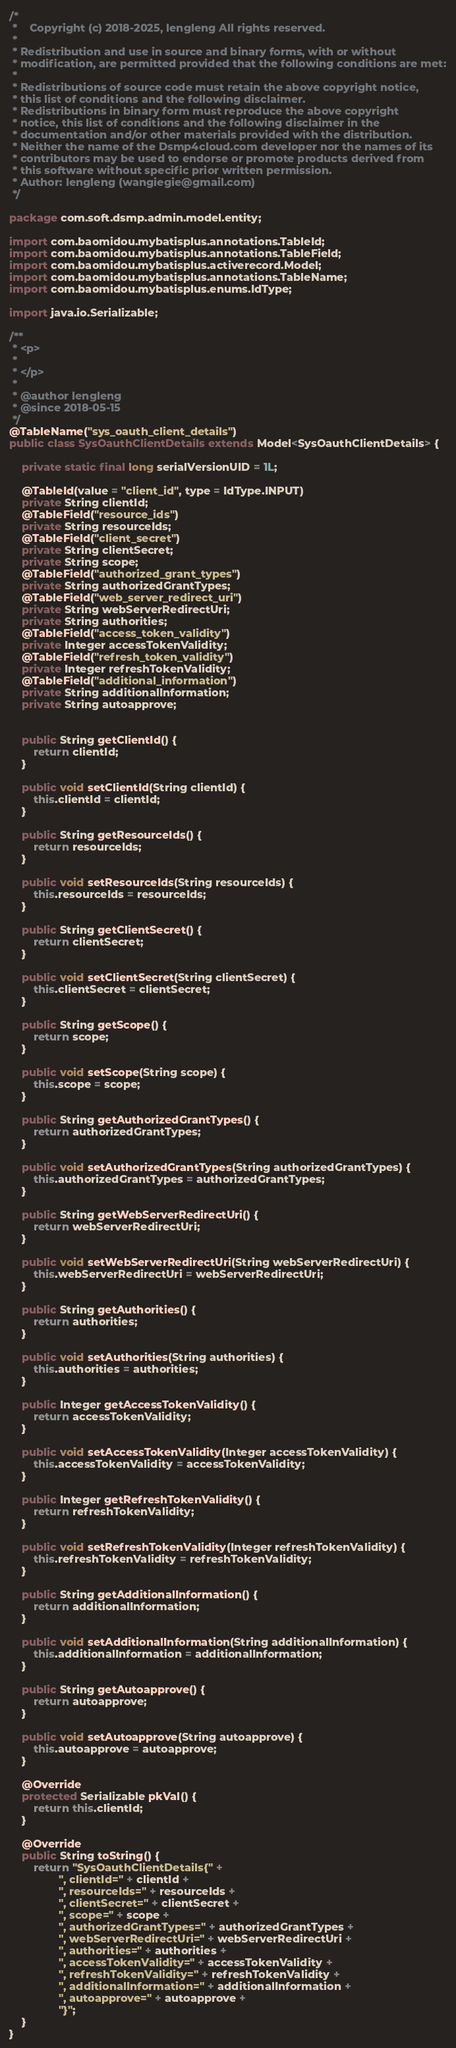<code> <loc_0><loc_0><loc_500><loc_500><_Java_>/*
 *    Copyright (c) 2018-2025, lengleng All rights reserved.
 *
 * Redistribution and use in source and binary forms, with or without
 * modification, are permitted provided that the following conditions are met:
 *
 * Redistributions of source code must retain the above copyright notice,
 * this list of conditions and the following disclaimer.
 * Redistributions in binary form must reproduce the above copyright
 * notice, this list of conditions and the following disclaimer in the
 * documentation and/or other materials provided with the distribution.
 * Neither the name of the Dsmp4cloud.com developer nor the names of its
 * contributors may be used to endorse or promote products derived from
 * this software without specific prior written permission.
 * Author: lengleng (wangiegie@gmail.com)
 */

package com.soft.dsmp.admin.model.entity;

import com.baomidou.mybatisplus.annotations.TableId;
import com.baomidou.mybatisplus.annotations.TableField;
import com.baomidou.mybatisplus.activerecord.Model;
import com.baomidou.mybatisplus.annotations.TableName;
import com.baomidou.mybatisplus.enums.IdType;

import java.io.Serializable;

/**
 * <p>
 *
 * </p>
 *
 * @author lengleng
 * @since 2018-05-15
 */
@TableName("sys_oauth_client_details")
public class SysOauthClientDetails extends Model<SysOauthClientDetails> {

    private static final long serialVersionUID = 1L;

    @TableId(value = "client_id", type = IdType.INPUT)
    private String clientId;
    @TableField("resource_ids")
    private String resourceIds;
    @TableField("client_secret")
    private String clientSecret;
    private String scope;
    @TableField("authorized_grant_types")
    private String authorizedGrantTypes;
    @TableField("web_server_redirect_uri")
    private String webServerRedirectUri;
    private String authorities;
    @TableField("access_token_validity")
    private Integer accessTokenValidity;
    @TableField("refresh_token_validity")
    private Integer refreshTokenValidity;
    @TableField("additional_information")
    private String additionalInformation;
    private String autoapprove;


    public String getClientId() {
        return clientId;
    }

    public void setClientId(String clientId) {
        this.clientId = clientId;
    }

    public String getResourceIds() {
        return resourceIds;
    }

    public void setResourceIds(String resourceIds) {
        this.resourceIds = resourceIds;
    }

    public String getClientSecret() {
        return clientSecret;
    }

    public void setClientSecret(String clientSecret) {
        this.clientSecret = clientSecret;
    }

    public String getScope() {
        return scope;
    }

    public void setScope(String scope) {
        this.scope = scope;
    }

    public String getAuthorizedGrantTypes() {
        return authorizedGrantTypes;
    }

    public void setAuthorizedGrantTypes(String authorizedGrantTypes) {
        this.authorizedGrantTypes = authorizedGrantTypes;
    }

    public String getWebServerRedirectUri() {
        return webServerRedirectUri;
    }

    public void setWebServerRedirectUri(String webServerRedirectUri) {
        this.webServerRedirectUri = webServerRedirectUri;
    }

    public String getAuthorities() {
        return authorities;
    }

    public void setAuthorities(String authorities) {
        this.authorities = authorities;
    }

    public Integer getAccessTokenValidity() {
        return accessTokenValidity;
    }

    public void setAccessTokenValidity(Integer accessTokenValidity) {
        this.accessTokenValidity = accessTokenValidity;
    }

    public Integer getRefreshTokenValidity() {
        return refreshTokenValidity;
    }

    public void setRefreshTokenValidity(Integer refreshTokenValidity) {
        this.refreshTokenValidity = refreshTokenValidity;
    }

    public String getAdditionalInformation() {
        return additionalInformation;
    }

    public void setAdditionalInformation(String additionalInformation) {
        this.additionalInformation = additionalInformation;
    }

    public String getAutoapprove() {
        return autoapprove;
    }

    public void setAutoapprove(String autoapprove) {
        this.autoapprove = autoapprove;
    }

    @Override
    protected Serializable pkVal() {
        return this.clientId;
    }

    @Override
    public String toString() {
        return "SysOauthClientDetails{" +
                ", clientId=" + clientId +
                ", resourceIds=" + resourceIds +
                ", clientSecret=" + clientSecret +
                ", scope=" + scope +
                ", authorizedGrantTypes=" + authorizedGrantTypes +
                ", webServerRedirectUri=" + webServerRedirectUri +
                ", authorities=" + authorities +
                ", accessTokenValidity=" + accessTokenValidity +
                ", refreshTokenValidity=" + refreshTokenValidity +
                ", additionalInformation=" + additionalInformation +
                ", autoapprove=" + autoapprove +
                "}";
    }
}
</code> 